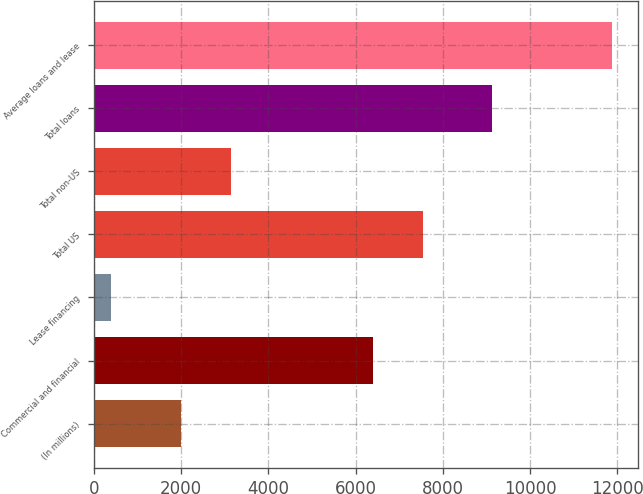Convert chart to OTSL. <chart><loc_0><loc_0><loc_500><loc_500><bar_chart><fcel>(In millions)<fcel>Commercial and financial<fcel>Lease financing<fcel>Total US<fcel>Total non-US<fcel>Total loans<fcel>Average loans and lease<nl><fcel>2008<fcel>6397<fcel>407<fcel>7544.7<fcel>3155.7<fcel>9131<fcel>11884<nl></chart> 